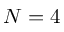Convert formula to latex. <formula><loc_0><loc_0><loc_500><loc_500>{ N = 4 }</formula> 